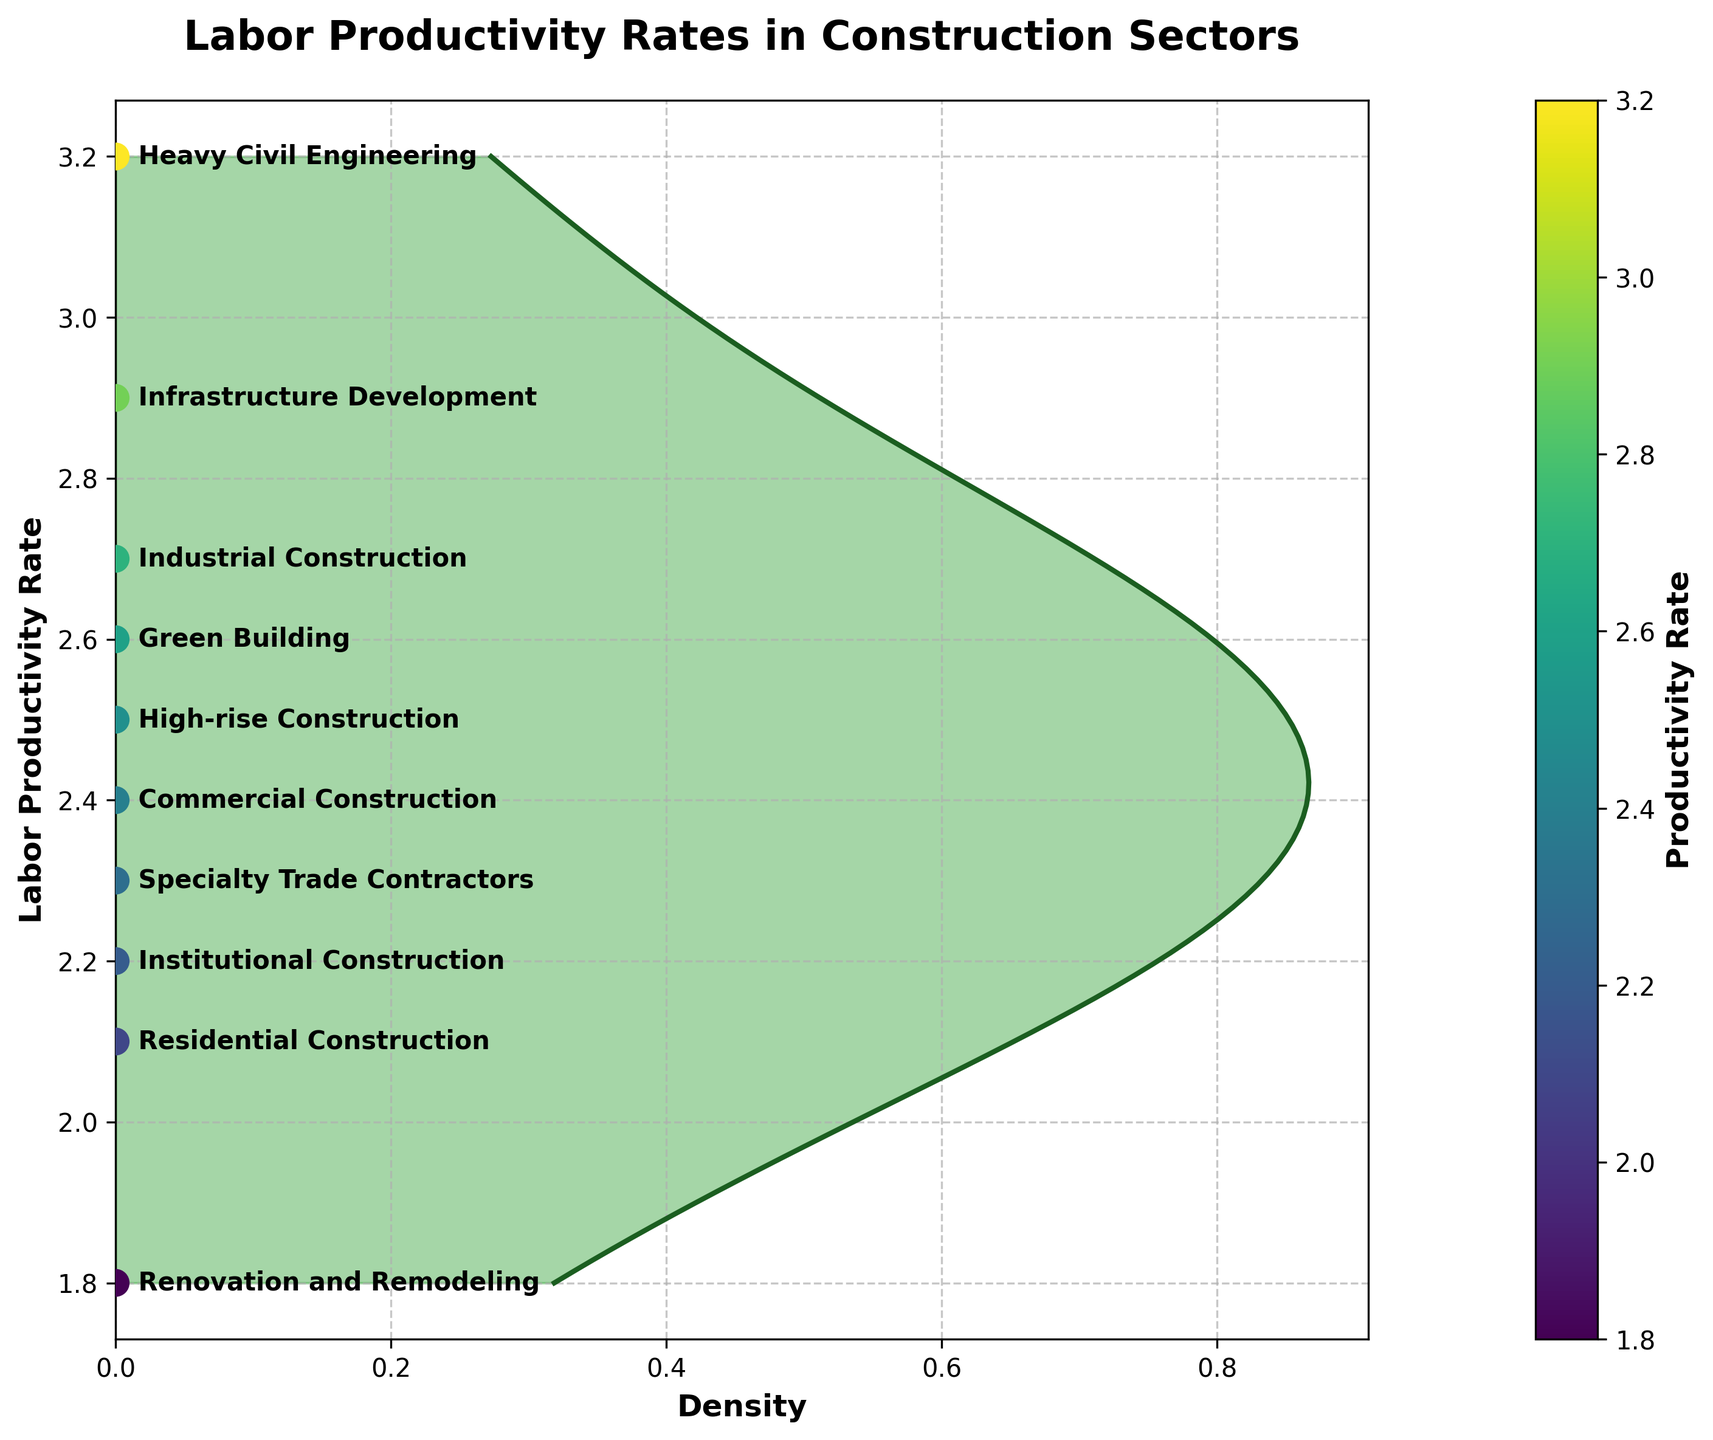What title is given to the figure? The title is typically located at the top of the figure. Here, it reads 'Labor Productivity Rates in Construction Sectors.'
Answer: 'Labor Productivity Rates in Construction Sectors' What is the highest labor productivity rate shown on the plot? To find the highest value, refer to the y-axis labels and identify the topmost value. The highest productivity rate is 3.2 in Heavy Civil Engineering.
Answer: 3.2 How many sectors are represented in the plot? By counting the number of distinct data points on the graph, it is possible to determine there are ten sectors represented.
Answer: 10 Which sector has the lowest productivity rate? Identify the lowest value on the y-axis, which corresponds to Renovation and Remodeling with a productivity rate of 1.8.
Answer: Renovation and Remodeling What is the average productivity rate across all sectors? To calculate the average, sum all productivity rates (2.1 + 2.4 + 2.7 + 3.2 + 2.9 + 1.8 + 2.3 + 2.6 + 2.5 + 2.2 = 24.7) and divide by the number of sectors (10). The average productivity rate is thus 2.47.
Answer: 2.47 Which sectors have productivity rates equal to or greater than 2.5? Inspect the y-axis and identify sectors with productivity rates at or above 2.5: Industrial Construction, Heavy Civil Engineering, Infrastructure Development, Green Building, and High-rise Construction.
Answer: Industrial Construction, Heavy Civil Engineering, Infrastructure Development, Green Building, High-rise Construction What is the range of productivity rates shown in the plot? The range is obtained by subtracting the lowest rate from the highest rate (3.2 - 1.8 = 1.4).
Answer: 1.4 How is the density of productivity rates visually represented in the plot? The density is depicted by the filled area along the productivity rate axis, with the gradient density computed by the kernel density estimation.
Answer: Filled area along the y-axis How does the density plot indicate the relative frequency of productivity rates? Higher densities (more shaded areas) correspond to higher relative frequencies of the productivity rates, signifying more sectors cluster around these values. The scatter points also illustrate this visually.
Answer: Higher densities reflect higher frequencies 